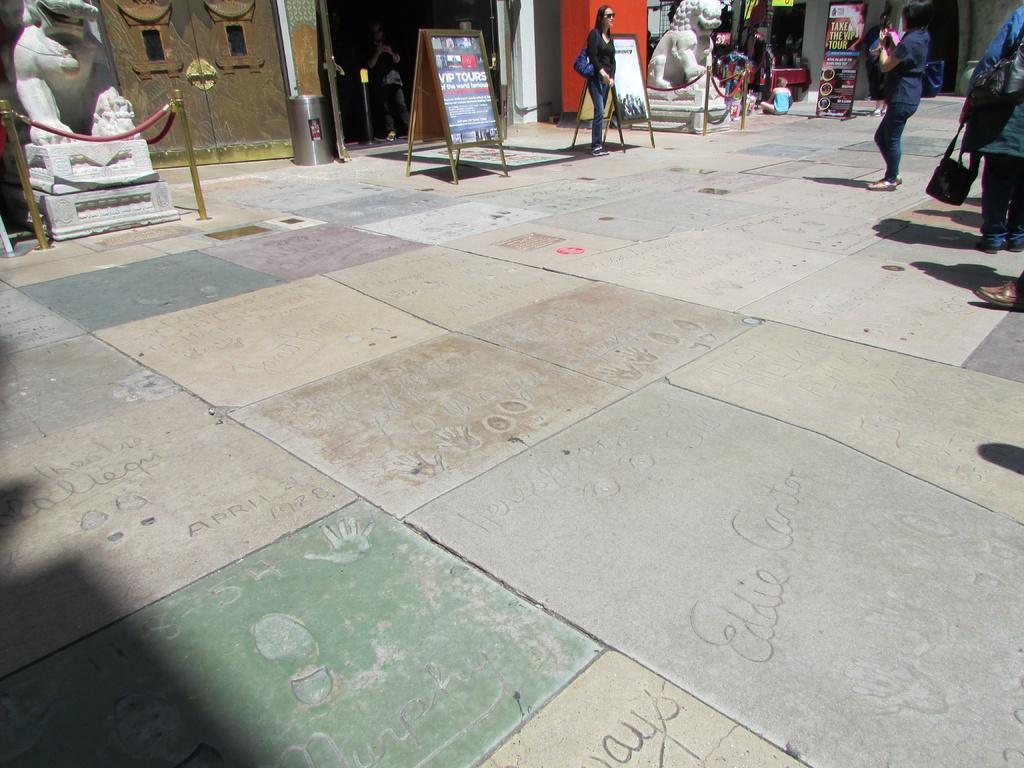Could you give a brief overview of what you see in this image? This picture shows couple of statues and couple of boards on the floor and we see a woman standing holding a bag and we see another woman standing and holding a mobile and taking picture and we see a man standing on the back. We see human holding a handbag and a bag in the hand and we see advertisement hoarding and human seated on the floor and we see a building and a dustbin. 